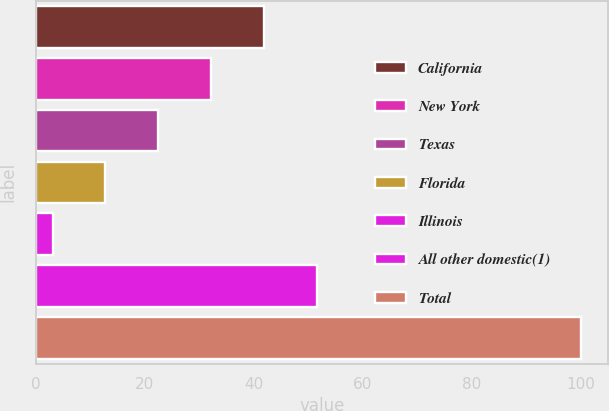<chart> <loc_0><loc_0><loc_500><loc_500><bar_chart><fcel>California<fcel>New York<fcel>Texas<fcel>Florida<fcel>Illinois<fcel>All other domestic(1)<fcel>Total<nl><fcel>41.86<fcel>32.17<fcel>22.48<fcel>12.79<fcel>3.1<fcel>51.55<fcel>100<nl></chart> 